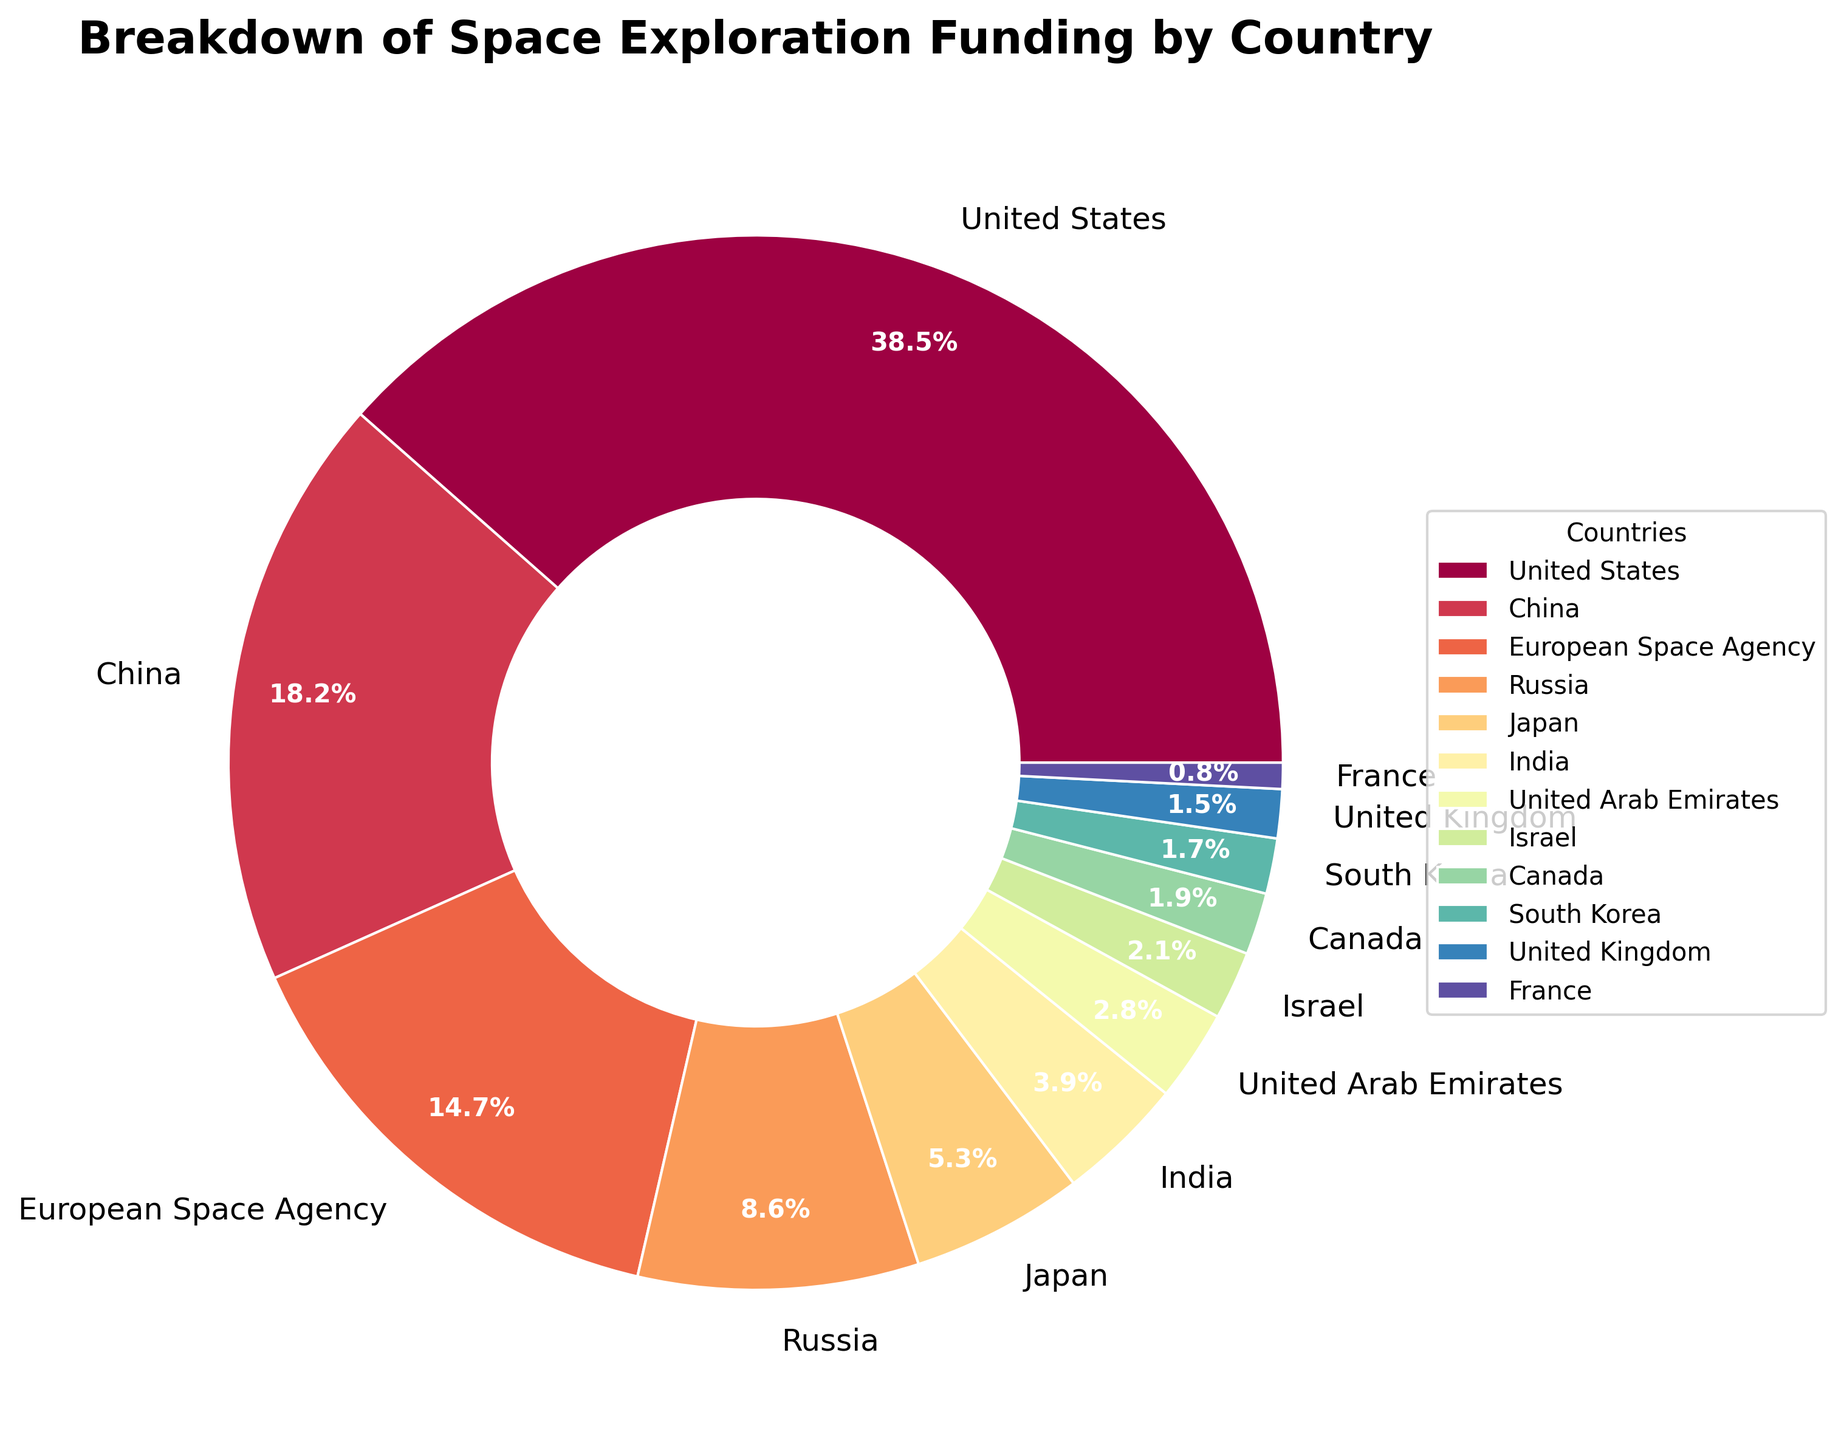Which country allocates the highest percentage of funding for space exploration? The figure shows the United States with the largest wedge, labeled with 38.5%, indicating that it has the highest allocation.
Answer: United States How much greater is the United States' funding percentage compared to China's? The United States' funding percentage is 38.5%, and China’s is 18.2%. Subtract China's percentage from the United States': 38.5 - 18.2 = 20.3%.
Answer: 20.3% Which countries contribute less than 2% each to space exploration funding? By observing the figure, the countries with wedges labeled with percentages less than 2% are South Korea, United Kingdom, and France.
Answer: South Korea, United Kingdom, France What is the combined funding percentage of the European Space Agency and Russia? The European Space Agency has 14.7% and Russia has 8.6%. Adding these gives: 14.7% + 8.6% = 23.3%.
Answer: 23.3% Which country has a similar funding percentage to Israel's 2.1%? The figure shows that no other country's wedge is labeled with exactly 2.1%. Thus, no country has the same funding percentage as Israel.
Answer: None Compare the funding percentages of India and Japan. Which is higher and by how much? Japan has a funding percentage of 5.3%, and India has 3.9%. Subtract India's percentage from Japan's: 5.3% - 3.9% = 1.4%. Japan's funding is higher by 1.4%.
Answer: Japan, by 1.4% Are there more countries contributing above or below 10% to space exploration funding? The countries with contributions above 10% are the United States (38.5%), China (18.2%), and European Space Agency (14.7%), totaling 3. The rest contribute below 10%, totaling 9. There are more countries contributing below 10%.
Answer: Below 10% What is the average funding percentage for Israel, Canada, and South Korea? The funding percentages for Israel, Canada, and South Korea are 2.1%, 1.9%, and 1.7%, respectively. Add these and divide by 3: (2.1 + 1.9 + 1.7) / 3 = 1.9%.
Answer: 1.9% How much greater is the European Space Agency's funding percentage compared to India's? The European Space Agency has 14.7% and India has 3.9%. Subtract India's percentage from the European Space Agency's: 14.7 - 3.9 = 10.8%.
Answer: 10.8% What percentage of funding is allocated by Japan, India, and United Arab Emirates combined? The funding percentages for Japan, India, and United Arab Emirates are 5.3%, 3.9%, and 2.8%, respectively. Add these: 5.3 + 3.9 + 2.8 = 12.0%.
Answer: 12.0% 